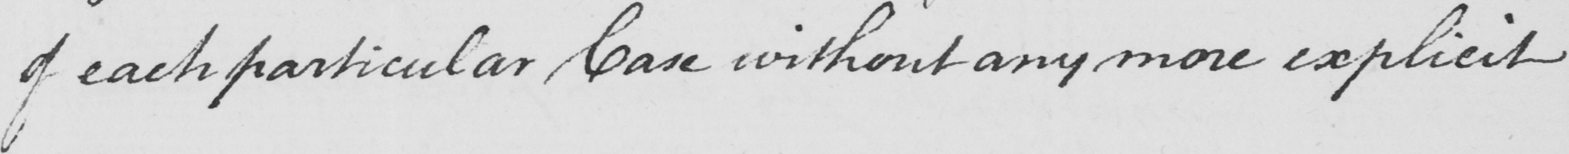Please provide the text content of this handwritten line. of each particular Case without any more explicit 